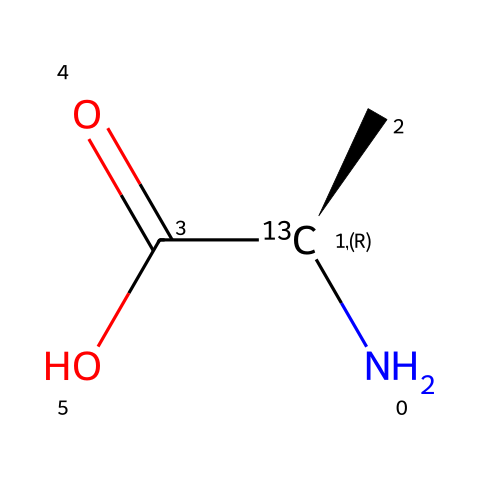What is the molecular formula of this structure? The SMILES representation indicates the presence of one nitrogen atom, two carbon atoms, and two oxygen atoms. Therefore, the molecular formula can be derived as C2H4N1O2.
Answer: C2H4N1O2 How many nitrogen atoms are present? By analyzing the SMILES, the character 'N' represents nitrogen. In this structure, there is one 'N', indicating the presence of one nitrogen atom.
Answer: 1 What type of functional group is indicated by “C(=O)O”? The notation “C(=O)O” shows that there is a carbon atom double bonded to an oxygen atom and also single bonded to another oxygen atom. This is characteristic of a carboxylic acid functional group.
Answer: carboxylic acid What is the significance of the “N[13C@H]” notation? The ‘N’ indicates the presence of nitrogen, and '[13C@H]' specifically denotes that the carbon atom is an isotope of carbon (Carbon-13). This implies that the amino acid is enriched with a stable isotope for tracing purposes.
Answer: Carbon-13 How many total rings are present in this structure? By looking at the SMILES representation, there are no cyclic structures visible, which indicates the presence of zero rings in this molecule.
Answer: 0 Is this compound hydrophobic or hydrophilic? The presence of the carboxylic acid functional group suggests that the compound is hydrophilic due to its ability to form hydrogen bonds with water molecules.
Answer: hydrophilic 